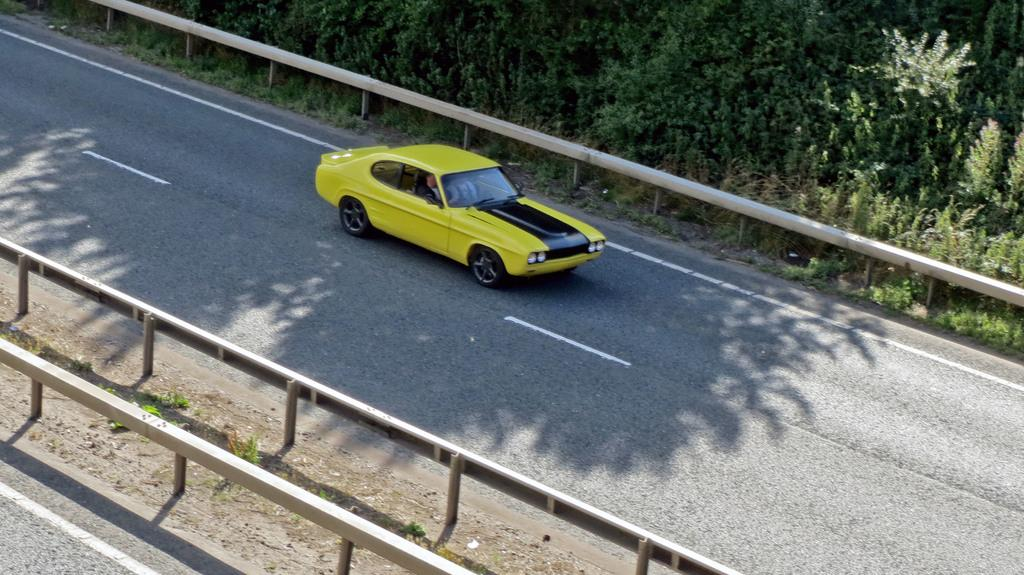What is the main feature of the image? There is a road in the image. What can be seen on the road? There is a yellow car on the road. What is located beside the road? There is railing beside the road. What type of vegetation is visible behind the railing? Plants and trees are present behind the railing. How many legs can be seen on the boy in the image? There is no boy present in the image, so it is not possible to determine the number of legs. What type of bells are hanging from the trees in the image? There are no bells visible in the image; only plants and trees are present behind the railing. 